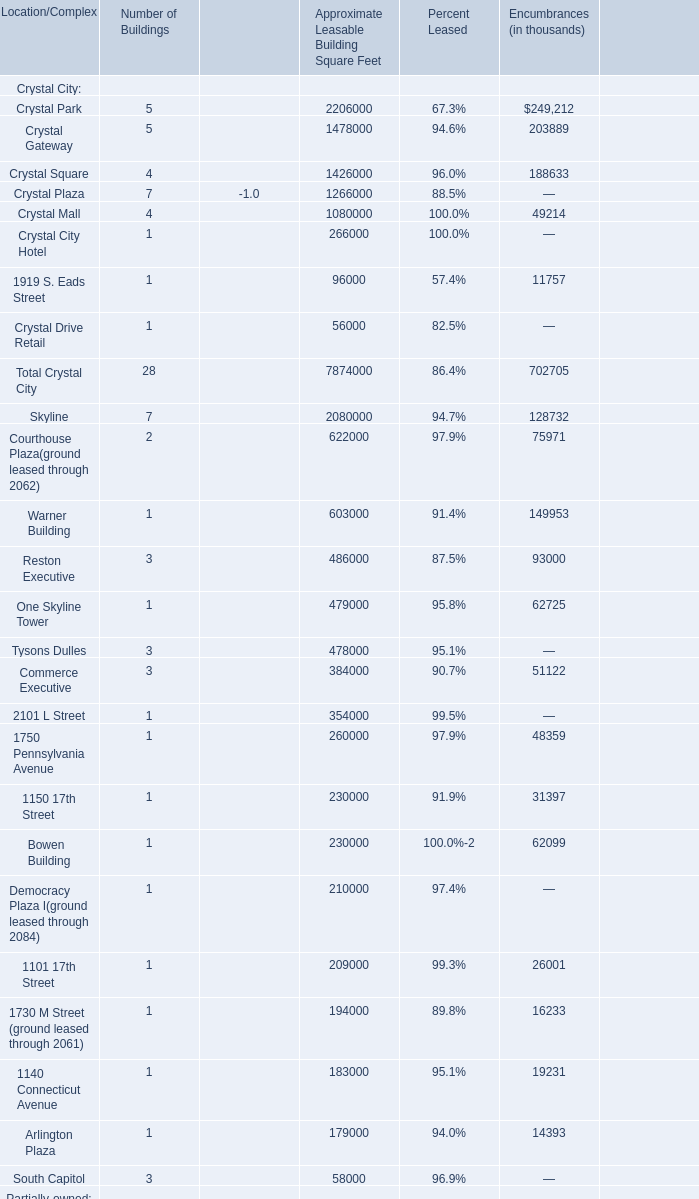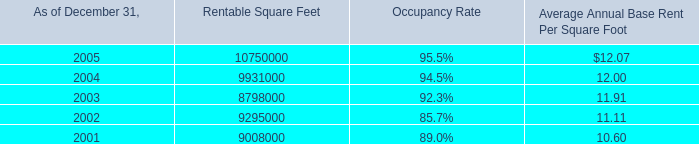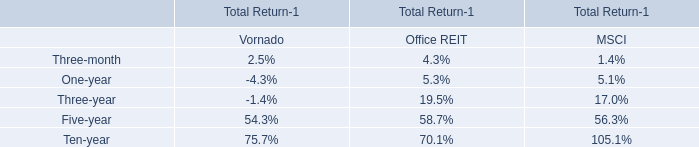How many is the Number of Buildings in terms of Crystal City Hotel less than the Total Number of Buildings in Crystal City? 
Computations: (28 - 1)
Answer: 27.0. 